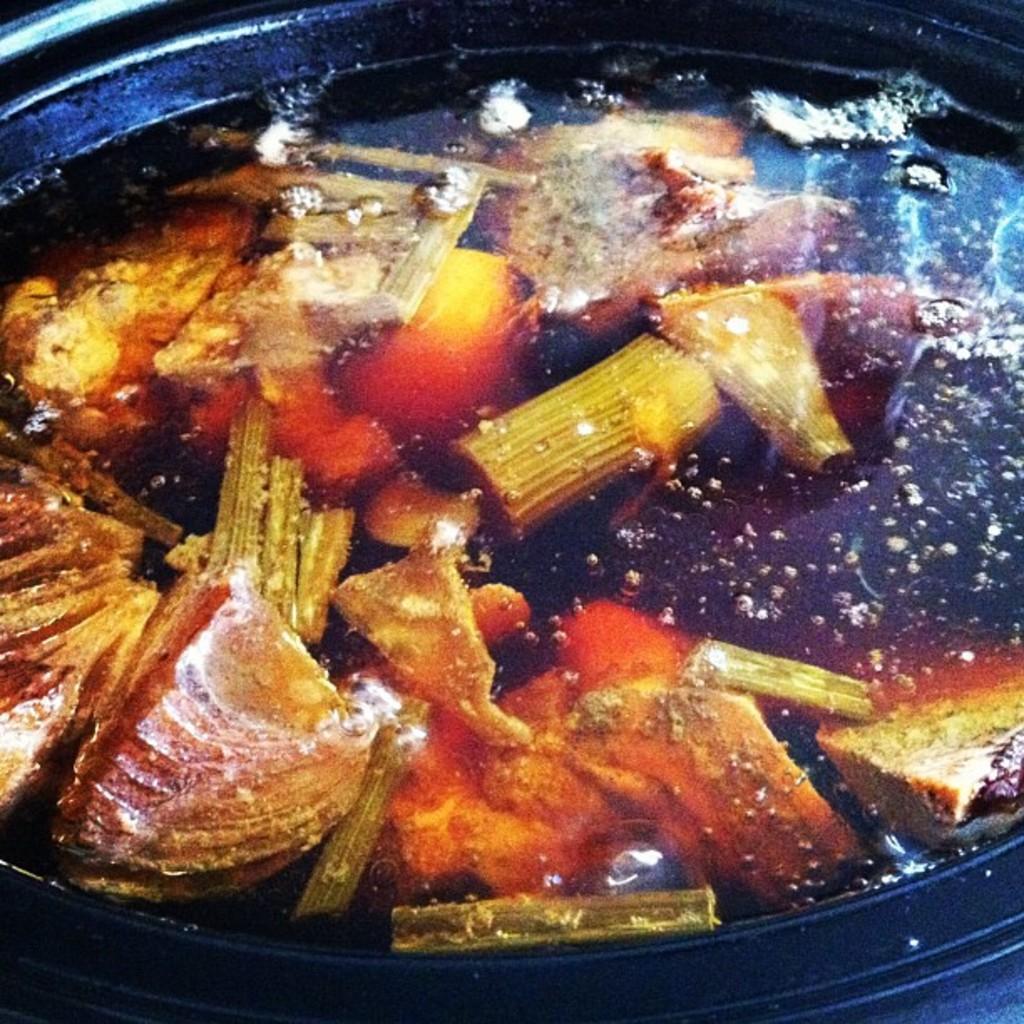How would you summarize this image in a sentence or two? In this picture I can see a food item in an iron skillet. 